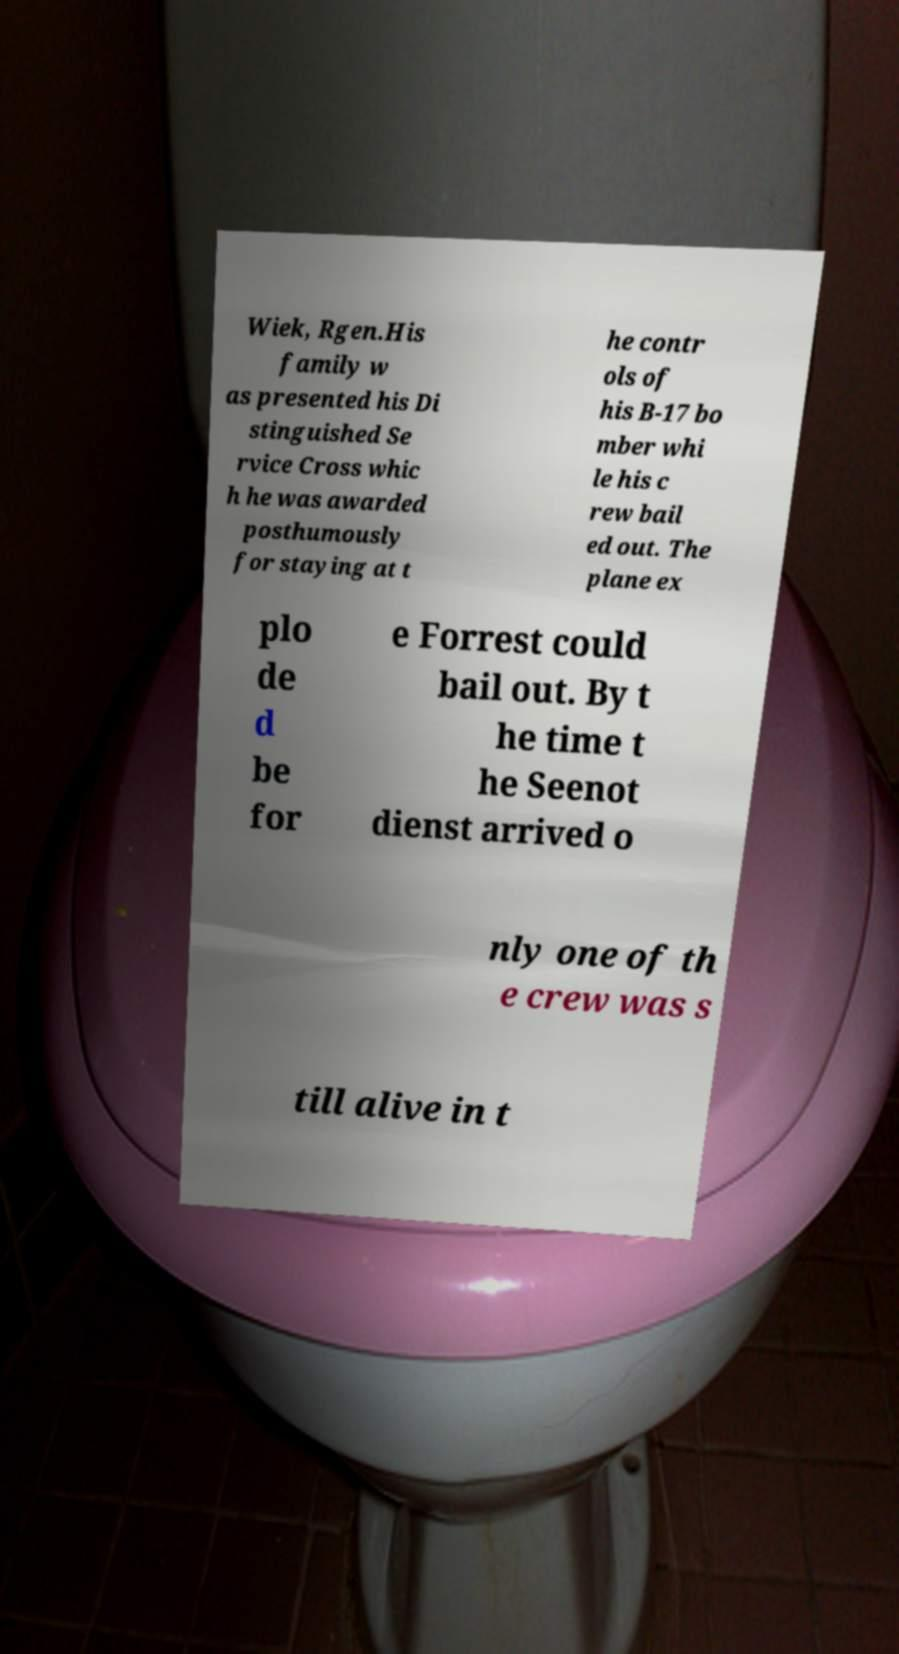For documentation purposes, I need the text within this image transcribed. Could you provide that? Wiek, Rgen.His family w as presented his Di stinguished Se rvice Cross whic h he was awarded posthumously for staying at t he contr ols of his B-17 bo mber whi le his c rew bail ed out. The plane ex plo de d be for e Forrest could bail out. By t he time t he Seenot dienst arrived o nly one of th e crew was s till alive in t 